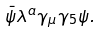Convert formula to latex. <formula><loc_0><loc_0><loc_500><loc_500>\bar { \psi } \lambda ^ { a } \gamma _ { \mu } \gamma _ { 5 } \psi .</formula> 